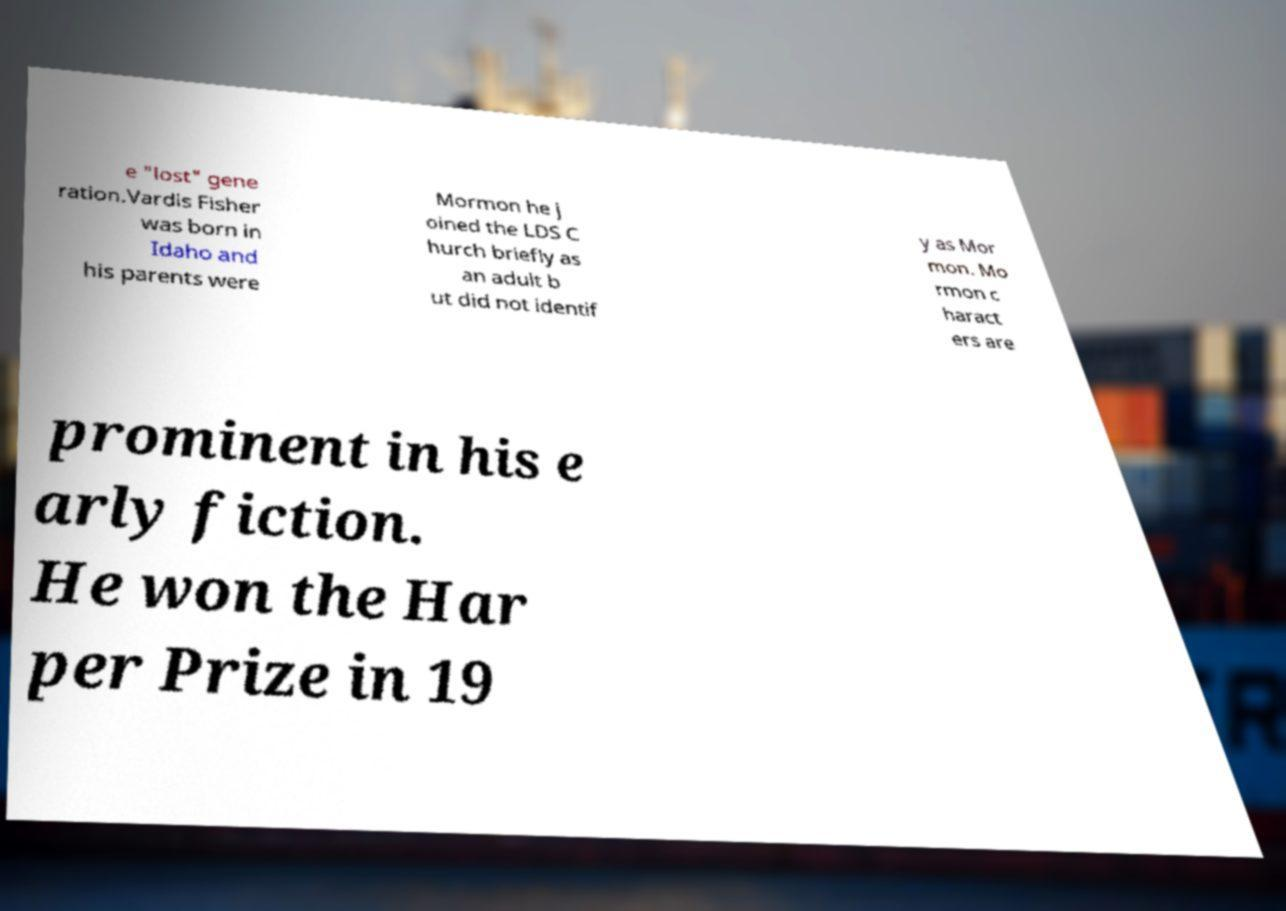Can you accurately transcribe the text from the provided image for me? e "lost" gene ration.Vardis Fisher was born in Idaho and his parents were Mormon he j oined the LDS C hurch briefly as an adult b ut did not identif y as Mor mon. Mo rmon c haract ers are prominent in his e arly fiction. He won the Har per Prize in 19 